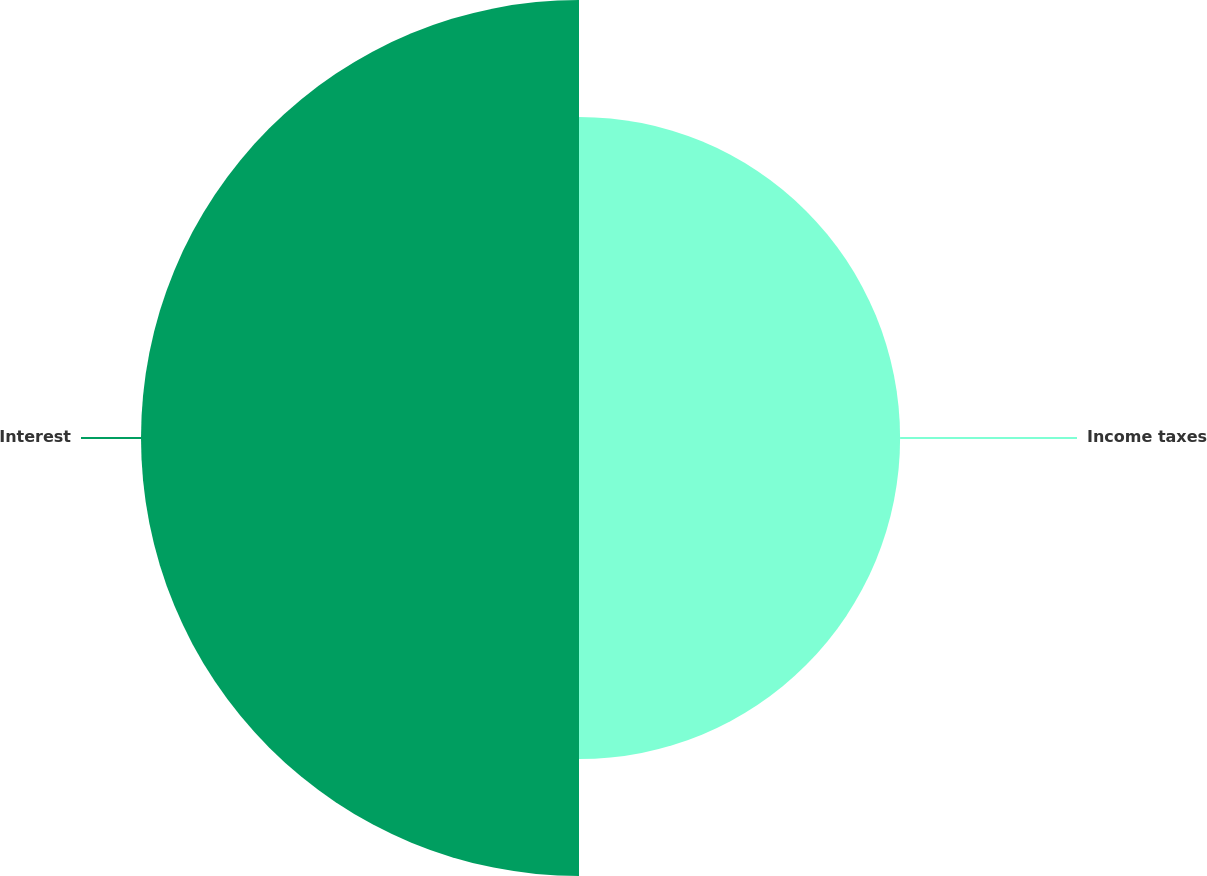Convert chart to OTSL. <chart><loc_0><loc_0><loc_500><loc_500><pie_chart><fcel>Income taxes<fcel>Interest<nl><fcel>42.3%<fcel>57.7%<nl></chart> 